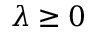Convert formula to latex. <formula><loc_0><loc_0><loc_500><loc_500>\lambda \geq 0</formula> 